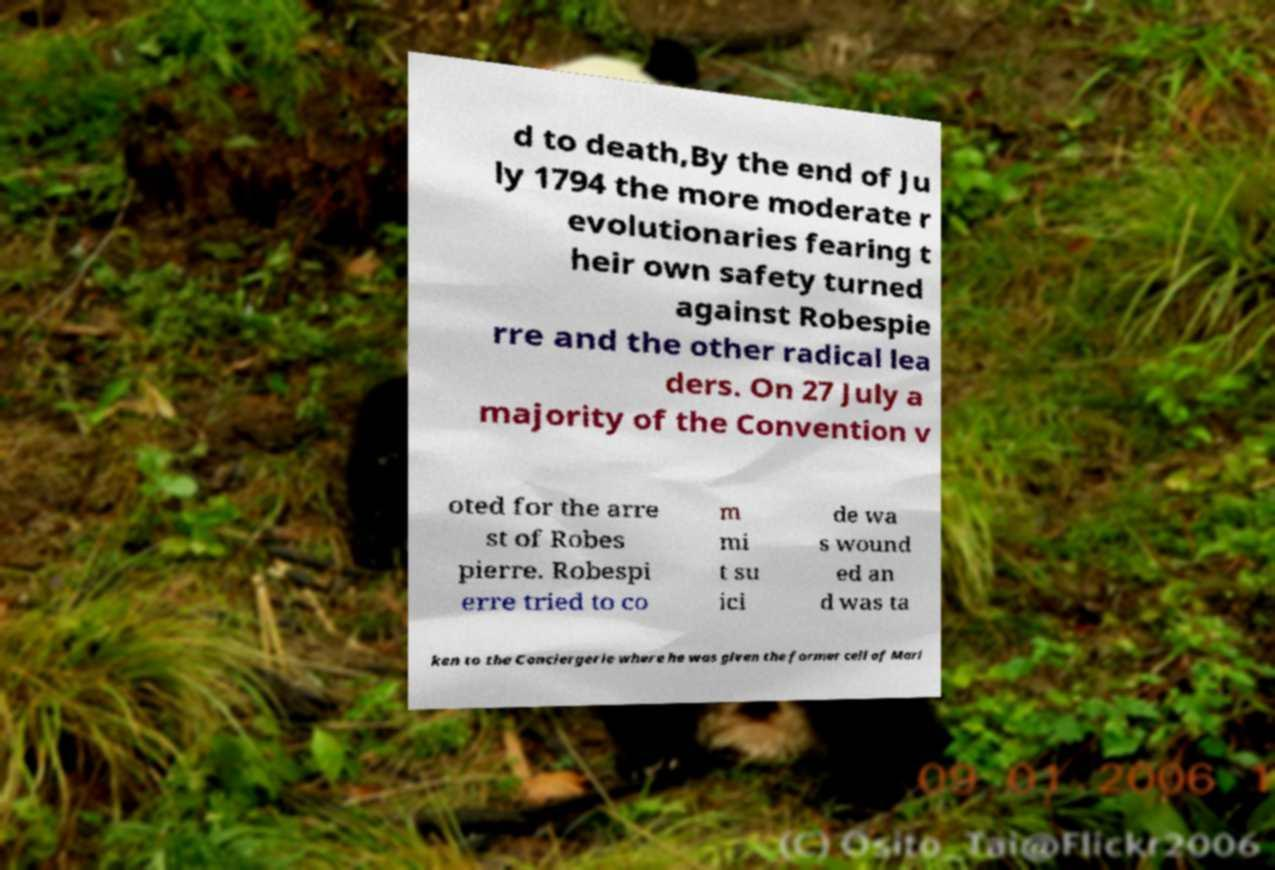I need the written content from this picture converted into text. Can you do that? d to death,By the end of Ju ly 1794 the more moderate r evolutionaries fearing t heir own safety turned against Robespie rre and the other radical lea ders. On 27 July a majority of the Convention v oted for the arre st of Robes pierre. Robespi erre tried to co m mi t su ici de wa s wound ed an d was ta ken to the Conciergerie where he was given the former cell of Mari 